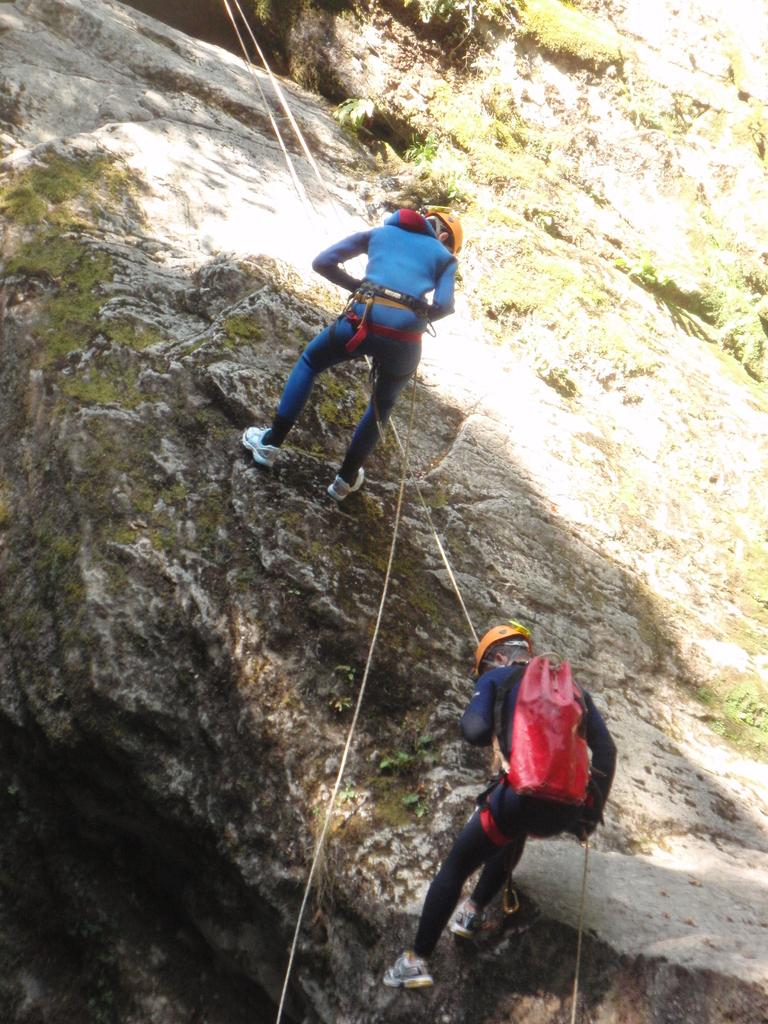Who is present in the image? There are people in the image. What activity are the people engaged in? The people are doing trekking. Where is the trekking taking place? The trekking is taking place on rock mountains. What type of pies can be seen in the image? There are no pies present in the image; it features people trekking on rock mountains. What type of scene is depicted in the image? The image depicts a scene of people trekking on rock mountains. 